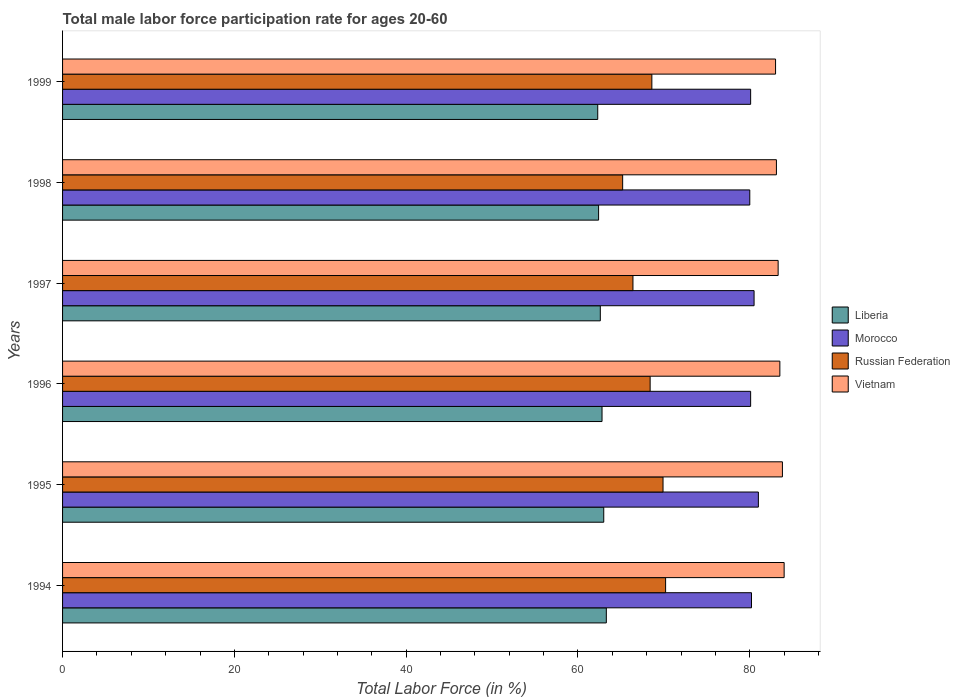How many groups of bars are there?
Offer a very short reply. 6. Are the number of bars per tick equal to the number of legend labels?
Provide a succinct answer. Yes. How many bars are there on the 4th tick from the top?
Offer a very short reply. 4. How many bars are there on the 2nd tick from the bottom?
Give a very brief answer. 4. What is the label of the 4th group of bars from the top?
Make the answer very short. 1996. What is the male labor force participation rate in Russian Federation in 1999?
Give a very brief answer. 68.6. Across all years, what is the maximum male labor force participation rate in Russian Federation?
Provide a succinct answer. 70.2. Across all years, what is the minimum male labor force participation rate in Russian Federation?
Provide a short and direct response. 65.2. In which year was the male labor force participation rate in Russian Federation maximum?
Make the answer very short. 1994. What is the total male labor force participation rate in Liberia in the graph?
Ensure brevity in your answer.  376.4. What is the difference between the male labor force participation rate in Morocco in 1994 and that in 1999?
Keep it short and to the point. 0.1. What is the average male labor force participation rate in Vietnam per year?
Provide a short and direct response. 83.45. In the year 1997, what is the difference between the male labor force participation rate in Vietnam and male labor force participation rate in Russian Federation?
Provide a short and direct response. 16.9. In how many years, is the male labor force participation rate in Morocco greater than 48 %?
Ensure brevity in your answer.  6. What is the ratio of the male labor force participation rate in Russian Federation in 1995 to that in 1996?
Provide a short and direct response. 1.02. What is the difference between the highest and the second highest male labor force participation rate in Russian Federation?
Your answer should be very brief. 0.3. What is the difference between the highest and the lowest male labor force participation rate in Russian Federation?
Ensure brevity in your answer.  5. What does the 1st bar from the top in 1997 represents?
Your answer should be very brief. Vietnam. What does the 1st bar from the bottom in 1998 represents?
Ensure brevity in your answer.  Liberia. How many bars are there?
Provide a succinct answer. 24. How many years are there in the graph?
Your answer should be very brief. 6. What is the difference between two consecutive major ticks on the X-axis?
Offer a very short reply. 20. Are the values on the major ticks of X-axis written in scientific E-notation?
Your answer should be compact. No. Does the graph contain any zero values?
Offer a very short reply. No. Does the graph contain grids?
Keep it short and to the point. No. Where does the legend appear in the graph?
Provide a short and direct response. Center right. How are the legend labels stacked?
Your response must be concise. Vertical. What is the title of the graph?
Keep it short and to the point. Total male labor force participation rate for ages 20-60. Does "Least developed countries" appear as one of the legend labels in the graph?
Give a very brief answer. No. What is the label or title of the X-axis?
Keep it short and to the point. Total Labor Force (in %). What is the Total Labor Force (in %) of Liberia in 1994?
Provide a succinct answer. 63.3. What is the Total Labor Force (in %) in Morocco in 1994?
Your answer should be very brief. 80.2. What is the Total Labor Force (in %) of Russian Federation in 1994?
Provide a succinct answer. 70.2. What is the Total Labor Force (in %) in Vietnam in 1994?
Make the answer very short. 84. What is the Total Labor Force (in %) of Liberia in 1995?
Make the answer very short. 63. What is the Total Labor Force (in %) in Morocco in 1995?
Ensure brevity in your answer.  81. What is the Total Labor Force (in %) of Russian Federation in 1995?
Provide a short and direct response. 69.9. What is the Total Labor Force (in %) in Vietnam in 1995?
Your response must be concise. 83.8. What is the Total Labor Force (in %) of Liberia in 1996?
Ensure brevity in your answer.  62.8. What is the Total Labor Force (in %) of Morocco in 1996?
Ensure brevity in your answer.  80.1. What is the Total Labor Force (in %) in Russian Federation in 1996?
Your answer should be compact. 68.4. What is the Total Labor Force (in %) of Vietnam in 1996?
Your response must be concise. 83.5. What is the Total Labor Force (in %) in Liberia in 1997?
Your answer should be compact. 62.6. What is the Total Labor Force (in %) in Morocco in 1997?
Offer a terse response. 80.5. What is the Total Labor Force (in %) of Russian Federation in 1997?
Your answer should be very brief. 66.4. What is the Total Labor Force (in %) of Vietnam in 1997?
Give a very brief answer. 83.3. What is the Total Labor Force (in %) in Liberia in 1998?
Your answer should be compact. 62.4. What is the Total Labor Force (in %) of Russian Federation in 1998?
Your answer should be compact. 65.2. What is the Total Labor Force (in %) of Vietnam in 1998?
Your response must be concise. 83.1. What is the Total Labor Force (in %) in Liberia in 1999?
Offer a very short reply. 62.3. What is the Total Labor Force (in %) in Morocco in 1999?
Offer a terse response. 80.1. What is the Total Labor Force (in %) in Russian Federation in 1999?
Your response must be concise. 68.6. What is the Total Labor Force (in %) in Vietnam in 1999?
Ensure brevity in your answer.  83. Across all years, what is the maximum Total Labor Force (in %) of Liberia?
Keep it short and to the point. 63.3. Across all years, what is the maximum Total Labor Force (in %) in Russian Federation?
Ensure brevity in your answer.  70.2. Across all years, what is the maximum Total Labor Force (in %) of Vietnam?
Give a very brief answer. 84. Across all years, what is the minimum Total Labor Force (in %) in Liberia?
Your response must be concise. 62.3. Across all years, what is the minimum Total Labor Force (in %) of Russian Federation?
Your answer should be compact. 65.2. Across all years, what is the minimum Total Labor Force (in %) of Vietnam?
Keep it short and to the point. 83. What is the total Total Labor Force (in %) in Liberia in the graph?
Your answer should be compact. 376.4. What is the total Total Labor Force (in %) in Morocco in the graph?
Your answer should be compact. 481.9. What is the total Total Labor Force (in %) in Russian Federation in the graph?
Provide a succinct answer. 408.7. What is the total Total Labor Force (in %) in Vietnam in the graph?
Your response must be concise. 500.7. What is the difference between the Total Labor Force (in %) of Morocco in 1994 and that in 1995?
Offer a very short reply. -0.8. What is the difference between the Total Labor Force (in %) in Russian Federation in 1994 and that in 1995?
Provide a succinct answer. 0.3. What is the difference between the Total Labor Force (in %) in Russian Federation in 1994 and that in 1996?
Give a very brief answer. 1.8. What is the difference between the Total Labor Force (in %) of Russian Federation in 1994 and that in 1997?
Give a very brief answer. 3.8. What is the difference between the Total Labor Force (in %) of Russian Federation in 1994 and that in 1998?
Your answer should be compact. 5. What is the difference between the Total Labor Force (in %) of Morocco in 1994 and that in 1999?
Provide a short and direct response. 0.1. What is the difference between the Total Labor Force (in %) of Vietnam in 1994 and that in 1999?
Make the answer very short. 1. What is the difference between the Total Labor Force (in %) in Russian Federation in 1995 and that in 1996?
Keep it short and to the point. 1.5. What is the difference between the Total Labor Force (in %) of Liberia in 1995 and that in 1998?
Your answer should be compact. 0.6. What is the difference between the Total Labor Force (in %) of Liberia in 1995 and that in 1999?
Provide a short and direct response. 0.7. What is the difference between the Total Labor Force (in %) of Russian Federation in 1995 and that in 1999?
Provide a succinct answer. 1.3. What is the difference between the Total Labor Force (in %) of Morocco in 1996 and that in 1997?
Offer a terse response. -0.4. What is the difference between the Total Labor Force (in %) in Russian Federation in 1996 and that in 1997?
Provide a succinct answer. 2. What is the difference between the Total Labor Force (in %) of Vietnam in 1996 and that in 1997?
Ensure brevity in your answer.  0.2. What is the difference between the Total Labor Force (in %) of Morocco in 1996 and that in 1998?
Your answer should be compact. 0.1. What is the difference between the Total Labor Force (in %) of Vietnam in 1996 and that in 1998?
Keep it short and to the point. 0.4. What is the difference between the Total Labor Force (in %) in Morocco in 1996 and that in 1999?
Your response must be concise. 0. What is the difference between the Total Labor Force (in %) of Russian Federation in 1996 and that in 1999?
Offer a very short reply. -0.2. What is the difference between the Total Labor Force (in %) in Vietnam in 1996 and that in 1999?
Your answer should be very brief. 0.5. What is the difference between the Total Labor Force (in %) of Liberia in 1997 and that in 1998?
Offer a terse response. 0.2. What is the difference between the Total Labor Force (in %) of Russian Federation in 1997 and that in 1998?
Make the answer very short. 1.2. What is the difference between the Total Labor Force (in %) in Morocco in 1997 and that in 1999?
Offer a terse response. 0.4. What is the difference between the Total Labor Force (in %) in Vietnam in 1997 and that in 1999?
Your answer should be compact. 0.3. What is the difference between the Total Labor Force (in %) in Liberia in 1998 and that in 1999?
Your answer should be very brief. 0.1. What is the difference between the Total Labor Force (in %) of Russian Federation in 1998 and that in 1999?
Keep it short and to the point. -3.4. What is the difference between the Total Labor Force (in %) in Vietnam in 1998 and that in 1999?
Provide a succinct answer. 0.1. What is the difference between the Total Labor Force (in %) of Liberia in 1994 and the Total Labor Force (in %) of Morocco in 1995?
Provide a short and direct response. -17.7. What is the difference between the Total Labor Force (in %) of Liberia in 1994 and the Total Labor Force (in %) of Russian Federation in 1995?
Provide a short and direct response. -6.6. What is the difference between the Total Labor Force (in %) of Liberia in 1994 and the Total Labor Force (in %) of Vietnam in 1995?
Offer a very short reply. -20.5. What is the difference between the Total Labor Force (in %) in Russian Federation in 1994 and the Total Labor Force (in %) in Vietnam in 1995?
Keep it short and to the point. -13.6. What is the difference between the Total Labor Force (in %) in Liberia in 1994 and the Total Labor Force (in %) in Morocco in 1996?
Keep it short and to the point. -16.8. What is the difference between the Total Labor Force (in %) of Liberia in 1994 and the Total Labor Force (in %) of Vietnam in 1996?
Your response must be concise. -20.2. What is the difference between the Total Labor Force (in %) of Morocco in 1994 and the Total Labor Force (in %) of Russian Federation in 1996?
Your answer should be very brief. 11.8. What is the difference between the Total Labor Force (in %) in Morocco in 1994 and the Total Labor Force (in %) in Vietnam in 1996?
Ensure brevity in your answer.  -3.3. What is the difference between the Total Labor Force (in %) in Liberia in 1994 and the Total Labor Force (in %) in Morocco in 1997?
Offer a terse response. -17.2. What is the difference between the Total Labor Force (in %) in Morocco in 1994 and the Total Labor Force (in %) in Russian Federation in 1997?
Give a very brief answer. 13.8. What is the difference between the Total Labor Force (in %) of Morocco in 1994 and the Total Labor Force (in %) of Vietnam in 1997?
Keep it short and to the point. -3.1. What is the difference between the Total Labor Force (in %) of Liberia in 1994 and the Total Labor Force (in %) of Morocco in 1998?
Your answer should be compact. -16.7. What is the difference between the Total Labor Force (in %) of Liberia in 1994 and the Total Labor Force (in %) of Vietnam in 1998?
Your response must be concise. -19.8. What is the difference between the Total Labor Force (in %) of Morocco in 1994 and the Total Labor Force (in %) of Russian Federation in 1998?
Make the answer very short. 15. What is the difference between the Total Labor Force (in %) of Russian Federation in 1994 and the Total Labor Force (in %) of Vietnam in 1998?
Your answer should be compact. -12.9. What is the difference between the Total Labor Force (in %) of Liberia in 1994 and the Total Labor Force (in %) of Morocco in 1999?
Provide a succinct answer. -16.8. What is the difference between the Total Labor Force (in %) of Liberia in 1994 and the Total Labor Force (in %) of Russian Federation in 1999?
Offer a very short reply. -5.3. What is the difference between the Total Labor Force (in %) of Liberia in 1994 and the Total Labor Force (in %) of Vietnam in 1999?
Your answer should be very brief. -19.7. What is the difference between the Total Labor Force (in %) in Morocco in 1994 and the Total Labor Force (in %) in Vietnam in 1999?
Provide a succinct answer. -2.8. What is the difference between the Total Labor Force (in %) of Liberia in 1995 and the Total Labor Force (in %) of Morocco in 1996?
Provide a short and direct response. -17.1. What is the difference between the Total Labor Force (in %) of Liberia in 1995 and the Total Labor Force (in %) of Vietnam in 1996?
Your response must be concise. -20.5. What is the difference between the Total Labor Force (in %) of Morocco in 1995 and the Total Labor Force (in %) of Russian Federation in 1996?
Offer a terse response. 12.6. What is the difference between the Total Labor Force (in %) in Morocco in 1995 and the Total Labor Force (in %) in Vietnam in 1996?
Provide a short and direct response. -2.5. What is the difference between the Total Labor Force (in %) of Liberia in 1995 and the Total Labor Force (in %) of Morocco in 1997?
Your answer should be compact. -17.5. What is the difference between the Total Labor Force (in %) of Liberia in 1995 and the Total Labor Force (in %) of Russian Federation in 1997?
Make the answer very short. -3.4. What is the difference between the Total Labor Force (in %) in Liberia in 1995 and the Total Labor Force (in %) in Vietnam in 1997?
Your answer should be compact. -20.3. What is the difference between the Total Labor Force (in %) of Morocco in 1995 and the Total Labor Force (in %) of Russian Federation in 1997?
Your answer should be very brief. 14.6. What is the difference between the Total Labor Force (in %) of Russian Federation in 1995 and the Total Labor Force (in %) of Vietnam in 1997?
Give a very brief answer. -13.4. What is the difference between the Total Labor Force (in %) in Liberia in 1995 and the Total Labor Force (in %) in Vietnam in 1998?
Keep it short and to the point. -20.1. What is the difference between the Total Labor Force (in %) of Morocco in 1995 and the Total Labor Force (in %) of Russian Federation in 1998?
Offer a terse response. 15.8. What is the difference between the Total Labor Force (in %) of Liberia in 1995 and the Total Labor Force (in %) of Morocco in 1999?
Make the answer very short. -17.1. What is the difference between the Total Labor Force (in %) in Morocco in 1995 and the Total Labor Force (in %) in Vietnam in 1999?
Make the answer very short. -2. What is the difference between the Total Labor Force (in %) of Liberia in 1996 and the Total Labor Force (in %) of Morocco in 1997?
Your answer should be very brief. -17.7. What is the difference between the Total Labor Force (in %) of Liberia in 1996 and the Total Labor Force (in %) of Russian Federation in 1997?
Your response must be concise. -3.6. What is the difference between the Total Labor Force (in %) in Liberia in 1996 and the Total Labor Force (in %) in Vietnam in 1997?
Ensure brevity in your answer.  -20.5. What is the difference between the Total Labor Force (in %) of Morocco in 1996 and the Total Labor Force (in %) of Vietnam in 1997?
Your answer should be compact. -3.2. What is the difference between the Total Labor Force (in %) of Russian Federation in 1996 and the Total Labor Force (in %) of Vietnam in 1997?
Your answer should be very brief. -14.9. What is the difference between the Total Labor Force (in %) in Liberia in 1996 and the Total Labor Force (in %) in Morocco in 1998?
Your answer should be very brief. -17.2. What is the difference between the Total Labor Force (in %) of Liberia in 1996 and the Total Labor Force (in %) of Vietnam in 1998?
Give a very brief answer. -20.3. What is the difference between the Total Labor Force (in %) in Russian Federation in 1996 and the Total Labor Force (in %) in Vietnam in 1998?
Provide a succinct answer. -14.7. What is the difference between the Total Labor Force (in %) of Liberia in 1996 and the Total Labor Force (in %) of Morocco in 1999?
Your answer should be very brief. -17.3. What is the difference between the Total Labor Force (in %) of Liberia in 1996 and the Total Labor Force (in %) of Russian Federation in 1999?
Provide a short and direct response. -5.8. What is the difference between the Total Labor Force (in %) in Liberia in 1996 and the Total Labor Force (in %) in Vietnam in 1999?
Give a very brief answer. -20.2. What is the difference between the Total Labor Force (in %) in Morocco in 1996 and the Total Labor Force (in %) in Vietnam in 1999?
Your answer should be compact. -2.9. What is the difference between the Total Labor Force (in %) of Russian Federation in 1996 and the Total Labor Force (in %) of Vietnam in 1999?
Your answer should be compact. -14.6. What is the difference between the Total Labor Force (in %) in Liberia in 1997 and the Total Labor Force (in %) in Morocco in 1998?
Provide a succinct answer. -17.4. What is the difference between the Total Labor Force (in %) of Liberia in 1997 and the Total Labor Force (in %) of Vietnam in 1998?
Keep it short and to the point. -20.5. What is the difference between the Total Labor Force (in %) of Morocco in 1997 and the Total Labor Force (in %) of Russian Federation in 1998?
Your response must be concise. 15.3. What is the difference between the Total Labor Force (in %) in Russian Federation in 1997 and the Total Labor Force (in %) in Vietnam in 1998?
Keep it short and to the point. -16.7. What is the difference between the Total Labor Force (in %) in Liberia in 1997 and the Total Labor Force (in %) in Morocco in 1999?
Your answer should be very brief. -17.5. What is the difference between the Total Labor Force (in %) in Liberia in 1997 and the Total Labor Force (in %) in Vietnam in 1999?
Offer a very short reply. -20.4. What is the difference between the Total Labor Force (in %) of Morocco in 1997 and the Total Labor Force (in %) of Russian Federation in 1999?
Provide a short and direct response. 11.9. What is the difference between the Total Labor Force (in %) of Russian Federation in 1997 and the Total Labor Force (in %) of Vietnam in 1999?
Your answer should be compact. -16.6. What is the difference between the Total Labor Force (in %) of Liberia in 1998 and the Total Labor Force (in %) of Morocco in 1999?
Provide a short and direct response. -17.7. What is the difference between the Total Labor Force (in %) in Liberia in 1998 and the Total Labor Force (in %) in Vietnam in 1999?
Provide a short and direct response. -20.6. What is the difference between the Total Labor Force (in %) in Morocco in 1998 and the Total Labor Force (in %) in Vietnam in 1999?
Offer a very short reply. -3. What is the difference between the Total Labor Force (in %) of Russian Federation in 1998 and the Total Labor Force (in %) of Vietnam in 1999?
Your answer should be very brief. -17.8. What is the average Total Labor Force (in %) in Liberia per year?
Your answer should be very brief. 62.73. What is the average Total Labor Force (in %) in Morocco per year?
Make the answer very short. 80.32. What is the average Total Labor Force (in %) of Russian Federation per year?
Your answer should be very brief. 68.12. What is the average Total Labor Force (in %) in Vietnam per year?
Your answer should be compact. 83.45. In the year 1994, what is the difference between the Total Labor Force (in %) of Liberia and Total Labor Force (in %) of Morocco?
Provide a succinct answer. -16.9. In the year 1994, what is the difference between the Total Labor Force (in %) in Liberia and Total Labor Force (in %) in Russian Federation?
Ensure brevity in your answer.  -6.9. In the year 1994, what is the difference between the Total Labor Force (in %) of Liberia and Total Labor Force (in %) of Vietnam?
Provide a short and direct response. -20.7. In the year 1994, what is the difference between the Total Labor Force (in %) in Morocco and Total Labor Force (in %) in Russian Federation?
Provide a short and direct response. 10. In the year 1995, what is the difference between the Total Labor Force (in %) in Liberia and Total Labor Force (in %) in Morocco?
Keep it short and to the point. -18. In the year 1995, what is the difference between the Total Labor Force (in %) in Liberia and Total Labor Force (in %) in Vietnam?
Ensure brevity in your answer.  -20.8. In the year 1995, what is the difference between the Total Labor Force (in %) in Morocco and Total Labor Force (in %) in Vietnam?
Your response must be concise. -2.8. In the year 1996, what is the difference between the Total Labor Force (in %) of Liberia and Total Labor Force (in %) of Morocco?
Give a very brief answer. -17.3. In the year 1996, what is the difference between the Total Labor Force (in %) in Liberia and Total Labor Force (in %) in Vietnam?
Your answer should be compact. -20.7. In the year 1996, what is the difference between the Total Labor Force (in %) of Morocco and Total Labor Force (in %) of Russian Federation?
Your response must be concise. 11.7. In the year 1996, what is the difference between the Total Labor Force (in %) of Morocco and Total Labor Force (in %) of Vietnam?
Offer a terse response. -3.4. In the year 1996, what is the difference between the Total Labor Force (in %) of Russian Federation and Total Labor Force (in %) of Vietnam?
Your answer should be compact. -15.1. In the year 1997, what is the difference between the Total Labor Force (in %) of Liberia and Total Labor Force (in %) of Morocco?
Your response must be concise. -17.9. In the year 1997, what is the difference between the Total Labor Force (in %) in Liberia and Total Labor Force (in %) in Vietnam?
Your answer should be very brief. -20.7. In the year 1997, what is the difference between the Total Labor Force (in %) in Morocco and Total Labor Force (in %) in Russian Federation?
Provide a succinct answer. 14.1. In the year 1997, what is the difference between the Total Labor Force (in %) in Russian Federation and Total Labor Force (in %) in Vietnam?
Your response must be concise. -16.9. In the year 1998, what is the difference between the Total Labor Force (in %) in Liberia and Total Labor Force (in %) in Morocco?
Provide a short and direct response. -17.6. In the year 1998, what is the difference between the Total Labor Force (in %) in Liberia and Total Labor Force (in %) in Russian Federation?
Ensure brevity in your answer.  -2.8. In the year 1998, what is the difference between the Total Labor Force (in %) in Liberia and Total Labor Force (in %) in Vietnam?
Provide a short and direct response. -20.7. In the year 1998, what is the difference between the Total Labor Force (in %) of Morocco and Total Labor Force (in %) of Russian Federation?
Ensure brevity in your answer.  14.8. In the year 1998, what is the difference between the Total Labor Force (in %) in Morocco and Total Labor Force (in %) in Vietnam?
Your answer should be compact. -3.1. In the year 1998, what is the difference between the Total Labor Force (in %) of Russian Federation and Total Labor Force (in %) of Vietnam?
Ensure brevity in your answer.  -17.9. In the year 1999, what is the difference between the Total Labor Force (in %) in Liberia and Total Labor Force (in %) in Morocco?
Give a very brief answer. -17.8. In the year 1999, what is the difference between the Total Labor Force (in %) in Liberia and Total Labor Force (in %) in Vietnam?
Your answer should be very brief. -20.7. In the year 1999, what is the difference between the Total Labor Force (in %) in Russian Federation and Total Labor Force (in %) in Vietnam?
Ensure brevity in your answer.  -14.4. What is the ratio of the Total Labor Force (in %) in Liberia in 1994 to that in 1995?
Provide a succinct answer. 1. What is the ratio of the Total Labor Force (in %) of Morocco in 1994 to that in 1995?
Make the answer very short. 0.99. What is the ratio of the Total Labor Force (in %) in Vietnam in 1994 to that in 1995?
Offer a very short reply. 1. What is the ratio of the Total Labor Force (in %) in Liberia in 1994 to that in 1996?
Provide a short and direct response. 1.01. What is the ratio of the Total Labor Force (in %) of Morocco in 1994 to that in 1996?
Ensure brevity in your answer.  1. What is the ratio of the Total Labor Force (in %) in Russian Federation in 1994 to that in 1996?
Ensure brevity in your answer.  1.03. What is the ratio of the Total Labor Force (in %) of Vietnam in 1994 to that in 1996?
Keep it short and to the point. 1.01. What is the ratio of the Total Labor Force (in %) in Liberia in 1994 to that in 1997?
Offer a terse response. 1.01. What is the ratio of the Total Labor Force (in %) of Morocco in 1994 to that in 1997?
Give a very brief answer. 1. What is the ratio of the Total Labor Force (in %) of Russian Federation in 1994 to that in 1997?
Your answer should be very brief. 1.06. What is the ratio of the Total Labor Force (in %) of Vietnam in 1994 to that in 1997?
Provide a short and direct response. 1.01. What is the ratio of the Total Labor Force (in %) in Liberia in 1994 to that in 1998?
Your response must be concise. 1.01. What is the ratio of the Total Labor Force (in %) in Russian Federation in 1994 to that in 1998?
Provide a succinct answer. 1.08. What is the ratio of the Total Labor Force (in %) in Vietnam in 1994 to that in 1998?
Keep it short and to the point. 1.01. What is the ratio of the Total Labor Force (in %) in Liberia in 1994 to that in 1999?
Give a very brief answer. 1.02. What is the ratio of the Total Labor Force (in %) of Russian Federation in 1994 to that in 1999?
Provide a short and direct response. 1.02. What is the ratio of the Total Labor Force (in %) in Vietnam in 1994 to that in 1999?
Offer a very short reply. 1.01. What is the ratio of the Total Labor Force (in %) in Liberia in 1995 to that in 1996?
Give a very brief answer. 1. What is the ratio of the Total Labor Force (in %) of Morocco in 1995 to that in 1996?
Provide a short and direct response. 1.01. What is the ratio of the Total Labor Force (in %) of Russian Federation in 1995 to that in 1996?
Ensure brevity in your answer.  1.02. What is the ratio of the Total Labor Force (in %) in Liberia in 1995 to that in 1997?
Provide a succinct answer. 1.01. What is the ratio of the Total Labor Force (in %) in Morocco in 1995 to that in 1997?
Your answer should be very brief. 1.01. What is the ratio of the Total Labor Force (in %) of Russian Federation in 1995 to that in 1997?
Make the answer very short. 1.05. What is the ratio of the Total Labor Force (in %) of Liberia in 1995 to that in 1998?
Provide a succinct answer. 1.01. What is the ratio of the Total Labor Force (in %) in Morocco in 1995 to that in 1998?
Your answer should be very brief. 1.01. What is the ratio of the Total Labor Force (in %) in Russian Federation in 1995 to that in 1998?
Offer a very short reply. 1.07. What is the ratio of the Total Labor Force (in %) in Vietnam in 1995 to that in 1998?
Give a very brief answer. 1.01. What is the ratio of the Total Labor Force (in %) of Liberia in 1995 to that in 1999?
Provide a succinct answer. 1.01. What is the ratio of the Total Labor Force (in %) in Morocco in 1995 to that in 1999?
Ensure brevity in your answer.  1.01. What is the ratio of the Total Labor Force (in %) of Russian Federation in 1995 to that in 1999?
Provide a short and direct response. 1.02. What is the ratio of the Total Labor Force (in %) in Vietnam in 1995 to that in 1999?
Offer a very short reply. 1.01. What is the ratio of the Total Labor Force (in %) of Russian Federation in 1996 to that in 1997?
Your response must be concise. 1.03. What is the ratio of the Total Labor Force (in %) in Liberia in 1996 to that in 1998?
Your answer should be very brief. 1.01. What is the ratio of the Total Labor Force (in %) in Morocco in 1996 to that in 1998?
Keep it short and to the point. 1. What is the ratio of the Total Labor Force (in %) in Russian Federation in 1996 to that in 1998?
Keep it short and to the point. 1.05. What is the ratio of the Total Labor Force (in %) in Vietnam in 1996 to that in 1998?
Make the answer very short. 1. What is the ratio of the Total Labor Force (in %) in Liberia in 1997 to that in 1998?
Keep it short and to the point. 1. What is the ratio of the Total Labor Force (in %) in Russian Federation in 1997 to that in 1998?
Provide a succinct answer. 1.02. What is the ratio of the Total Labor Force (in %) of Morocco in 1997 to that in 1999?
Your answer should be very brief. 1. What is the ratio of the Total Labor Force (in %) in Russian Federation in 1997 to that in 1999?
Offer a terse response. 0.97. What is the ratio of the Total Labor Force (in %) of Morocco in 1998 to that in 1999?
Your answer should be very brief. 1. What is the ratio of the Total Labor Force (in %) of Russian Federation in 1998 to that in 1999?
Your response must be concise. 0.95. What is the ratio of the Total Labor Force (in %) in Vietnam in 1998 to that in 1999?
Offer a terse response. 1. What is the difference between the highest and the second highest Total Labor Force (in %) in Morocco?
Your answer should be compact. 0.5. What is the difference between the highest and the lowest Total Labor Force (in %) in Morocco?
Ensure brevity in your answer.  1. 